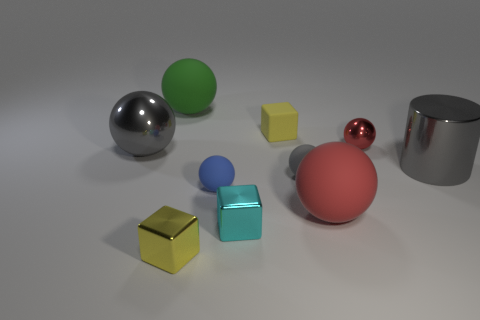Subtract all blue balls. How many balls are left? 5 Subtract all green spheres. How many spheres are left? 5 Subtract all purple balls. Subtract all red cubes. How many balls are left? 6 Subtract all spheres. How many objects are left? 4 Add 4 small yellow metal objects. How many small yellow metal objects exist? 5 Subtract 0 cyan spheres. How many objects are left? 10 Subtract all small metallic objects. Subtract all tiny red metallic cylinders. How many objects are left? 7 Add 2 green balls. How many green balls are left? 3 